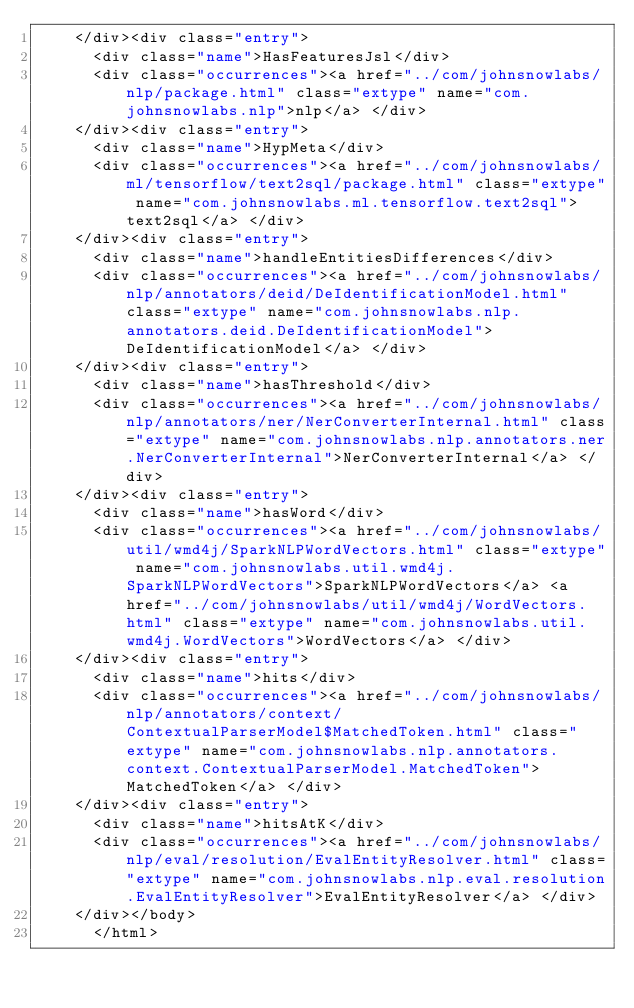Convert code to text. <code><loc_0><loc_0><loc_500><loc_500><_HTML_>    </div><div class="entry">
      <div class="name">HasFeaturesJsl</div>
      <div class="occurrences"><a href="../com/johnsnowlabs/nlp/package.html" class="extype" name="com.johnsnowlabs.nlp">nlp</a> </div>
    </div><div class="entry">
      <div class="name">HypMeta</div>
      <div class="occurrences"><a href="../com/johnsnowlabs/ml/tensorflow/text2sql/package.html" class="extype" name="com.johnsnowlabs.ml.tensorflow.text2sql">text2sql</a> </div>
    </div><div class="entry">
      <div class="name">handleEntitiesDifferences</div>
      <div class="occurrences"><a href="../com/johnsnowlabs/nlp/annotators/deid/DeIdentificationModel.html" class="extype" name="com.johnsnowlabs.nlp.annotators.deid.DeIdentificationModel">DeIdentificationModel</a> </div>
    </div><div class="entry">
      <div class="name">hasThreshold</div>
      <div class="occurrences"><a href="../com/johnsnowlabs/nlp/annotators/ner/NerConverterInternal.html" class="extype" name="com.johnsnowlabs.nlp.annotators.ner.NerConverterInternal">NerConverterInternal</a> </div>
    </div><div class="entry">
      <div class="name">hasWord</div>
      <div class="occurrences"><a href="../com/johnsnowlabs/util/wmd4j/SparkNLPWordVectors.html" class="extype" name="com.johnsnowlabs.util.wmd4j.SparkNLPWordVectors">SparkNLPWordVectors</a> <a href="../com/johnsnowlabs/util/wmd4j/WordVectors.html" class="extype" name="com.johnsnowlabs.util.wmd4j.WordVectors">WordVectors</a> </div>
    </div><div class="entry">
      <div class="name">hits</div>
      <div class="occurrences"><a href="../com/johnsnowlabs/nlp/annotators/context/ContextualParserModel$MatchedToken.html" class="extype" name="com.johnsnowlabs.nlp.annotators.context.ContextualParserModel.MatchedToken">MatchedToken</a> </div>
    </div><div class="entry">
      <div class="name">hitsAtK</div>
      <div class="occurrences"><a href="../com/johnsnowlabs/nlp/eval/resolution/EvalEntityResolver.html" class="extype" name="com.johnsnowlabs.nlp.eval.resolution.EvalEntityResolver">EvalEntityResolver</a> </div>
    </div></body>
      </html>
</code> 